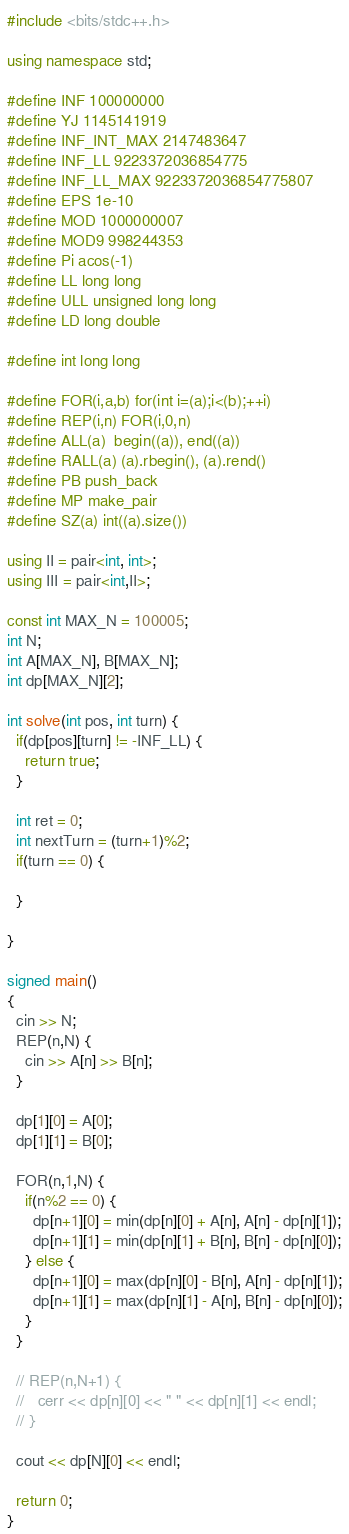<code> <loc_0><loc_0><loc_500><loc_500><_C++_>#include <bits/stdc++.h>

using namespace std;

#define INF 100000000
#define YJ 1145141919
#define INF_INT_MAX 2147483647
#define INF_LL 9223372036854775
#define INF_LL_MAX 9223372036854775807
#define EPS 1e-10
#define MOD 1000000007
#define MOD9 998244353
#define Pi acos(-1)
#define LL long long
#define ULL unsigned long long
#define LD long double

#define int long long

#define FOR(i,a,b) for(int i=(a);i<(b);++i)
#define REP(i,n) FOR(i,0,n)
#define ALL(a)  begin((a)), end((a))
#define RALL(a) (a).rbegin(), (a).rend()
#define PB push_back
#define MP make_pair
#define SZ(a) int((a).size())

using II = pair<int, int>;
using III = pair<int,II>;

const int MAX_N = 100005;
int N;
int A[MAX_N], B[MAX_N];
int dp[MAX_N][2];

int solve(int pos, int turn) {
  if(dp[pos][turn] != -INF_LL) {
    return true;
  }

  int ret = 0;
  int nextTurn = (turn+1)%2;
  if(turn == 0) {
    
  }

}

signed main()
{
  cin >> N;
  REP(n,N) {
    cin >> A[n] >> B[n];
  }

  dp[1][0] = A[0];
  dp[1][1] = B[0];

  FOR(n,1,N) {
    if(n%2 == 0) {
      dp[n+1][0] = min(dp[n][0] + A[n], A[n] - dp[n][1]);
      dp[n+1][1] = min(dp[n][1] + B[n], B[n] - dp[n][0]);
    } else {
      dp[n+1][0] = max(dp[n][0] - B[n], A[n] - dp[n][1]);
      dp[n+1][1] = max(dp[n][1] - A[n], B[n] - dp[n][0]);
    }
  }

  // REP(n,N+1) {
  //   cerr << dp[n][0] << " " << dp[n][1] << endl;
  // }

  cout << dp[N][0] << endl;

  return 0;
}
</code> 